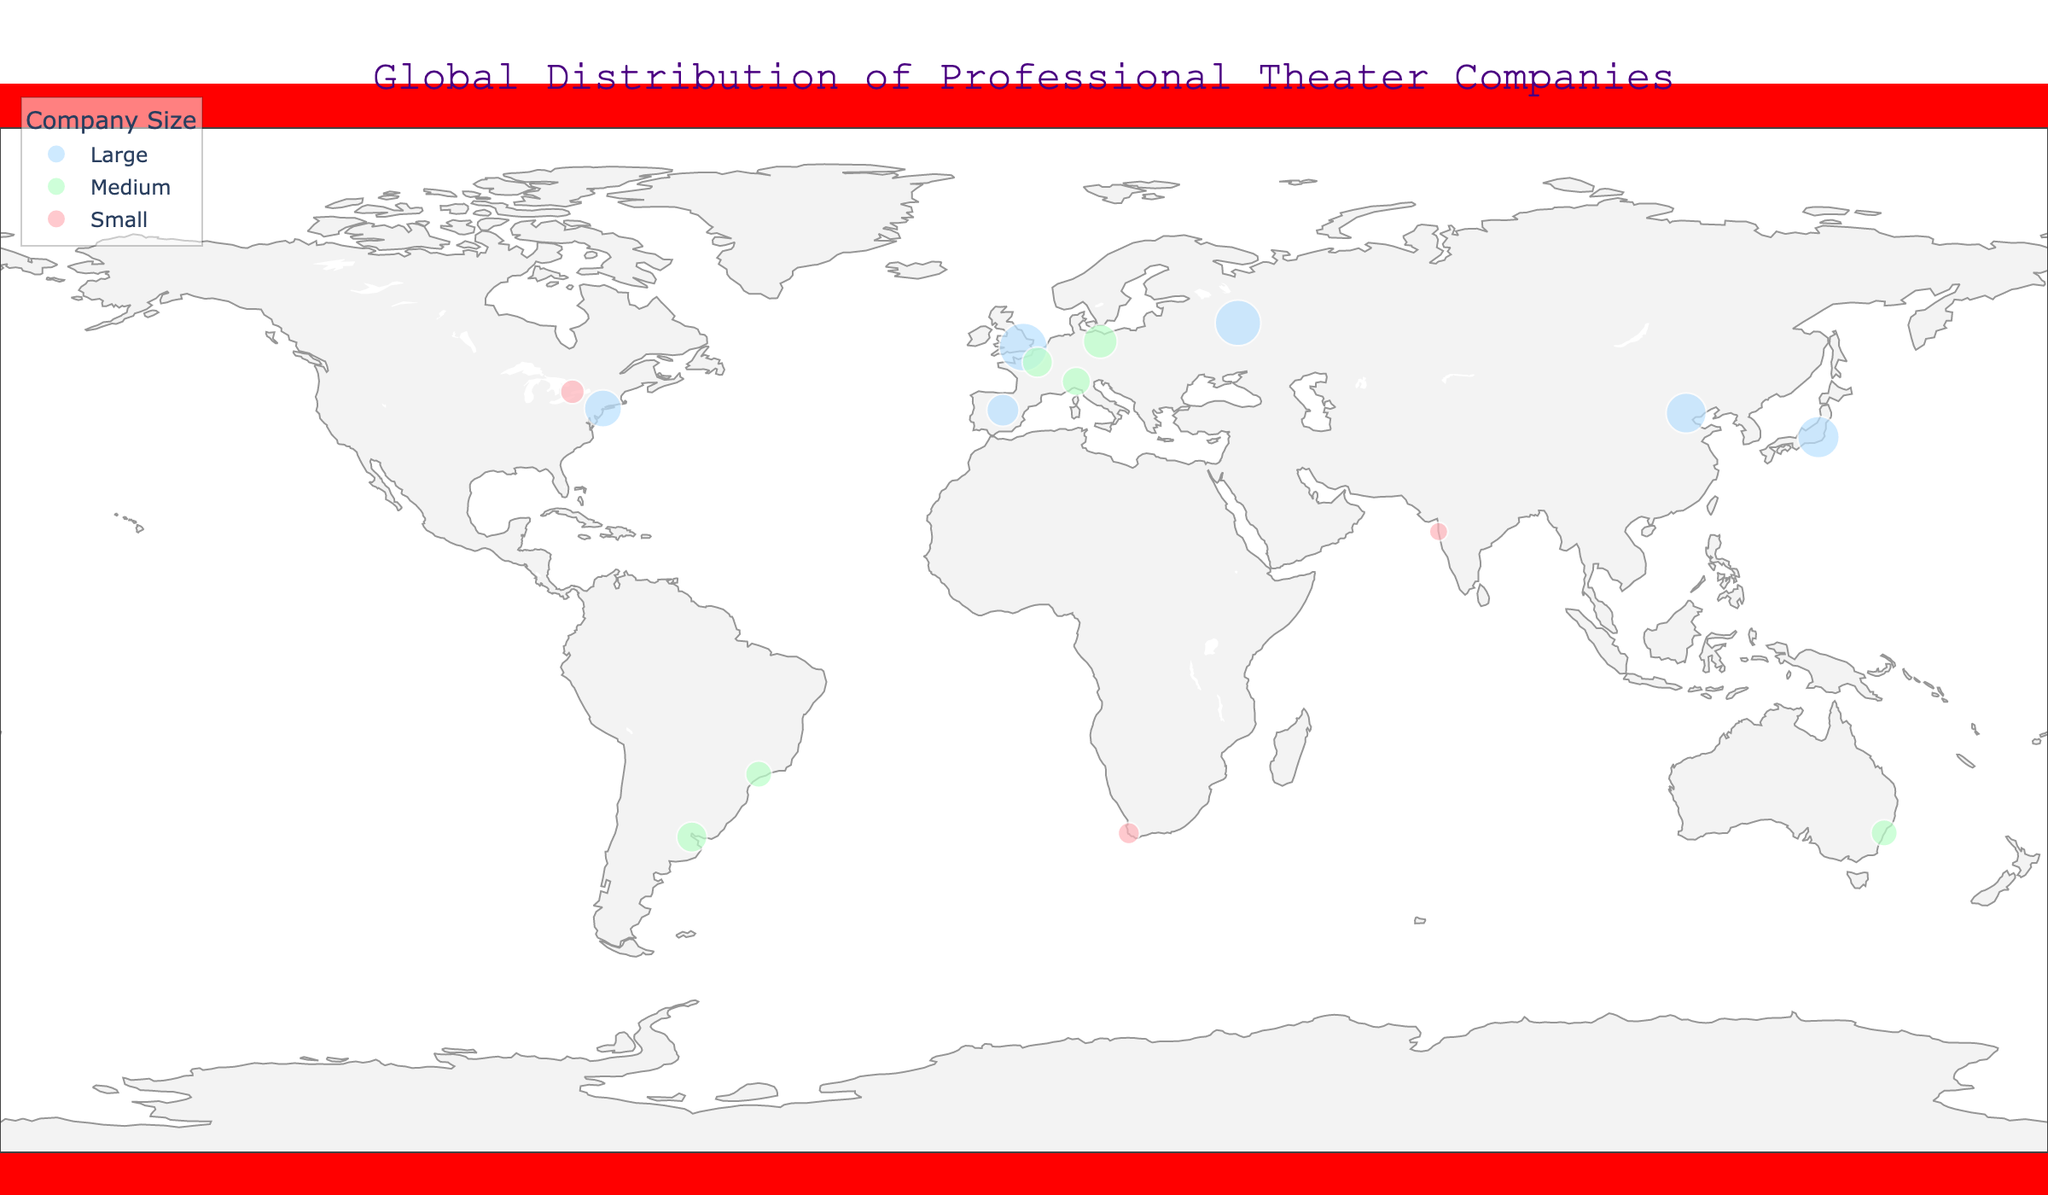What is the title of the figure? The title of the figure is displayed prominently at the top and typically in a larger font size to capture attention.
Answer: Global Distribution of Professional Theater Companies How many theater companies are shown on the map? Each data point on the map represents a theater company, usually indicated by a marker. Count the number of markers visible on the figure.
Answer: 14 Which city has the highest annual production for a single theater company? Observe the data to find the marker corresponding to the largest theater company’s annual productions. Check the hover information for each to find the highest value.
Answer: London What is the average number of annual productions for medium-sized theater companies? Sum the annual productions for all medium-sized companies and divide by the number of these companies: (8 + 10 + 6 + 7 + 6 + 8) / 6 = 45 / 6.
Answer: 7.5 How many large theater companies are there, and which continents do they belong to? Identify the markers representing large theater companies (based on size) and note their geographic location.
Answer: 6; North America, Europe, Asia Compare the annual productions of the theater companies in New York and Tokyo. Which one is higher? Find the data points for New York and Tokyo, check their annual productions, and compare the values.
Answer: Tokyo (15) is higher than New York (12) Which city in South America has a medium-sized theater company, and what's its annual production? Locate the medium-sized theater company in South America by identifying the region and checking for size. Hover over this marker to find its annual production.
Answer: Buenos Aires; 8 What color represents small theater companies on the map? The legend indicates the color associated with each company size. Match the color described for small theater companies.
Answer: Pink (a shade of pink) Between the theater companies in Paris and Berlin, which one has more annual productions? Hover over the markers for Paris and Berlin and compare the number of annual productions listed.
Answer: Berlin (10) has more than Paris (8) How does the map visually differentiate between theater companies of different sizes? The legend shows different colors for different sizes while the markers' sizes correspond to the number of annual productions.
Answer: Colors and marker sizes 